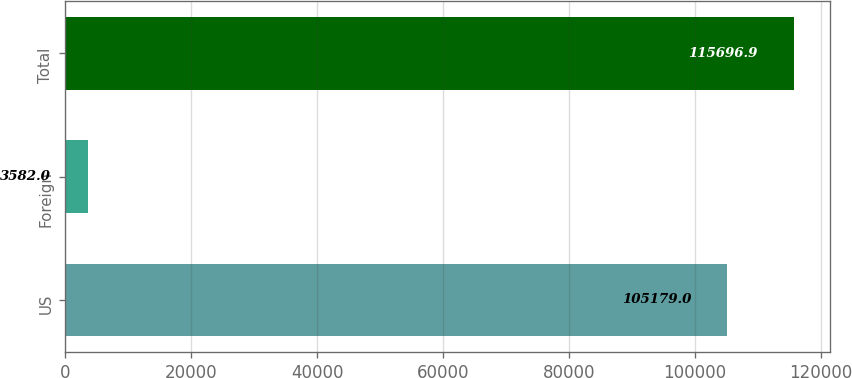Convert chart to OTSL. <chart><loc_0><loc_0><loc_500><loc_500><bar_chart><fcel>US<fcel>Foreign<fcel>Total<nl><fcel>105179<fcel>3582<fcel>115697<nl></chart> 